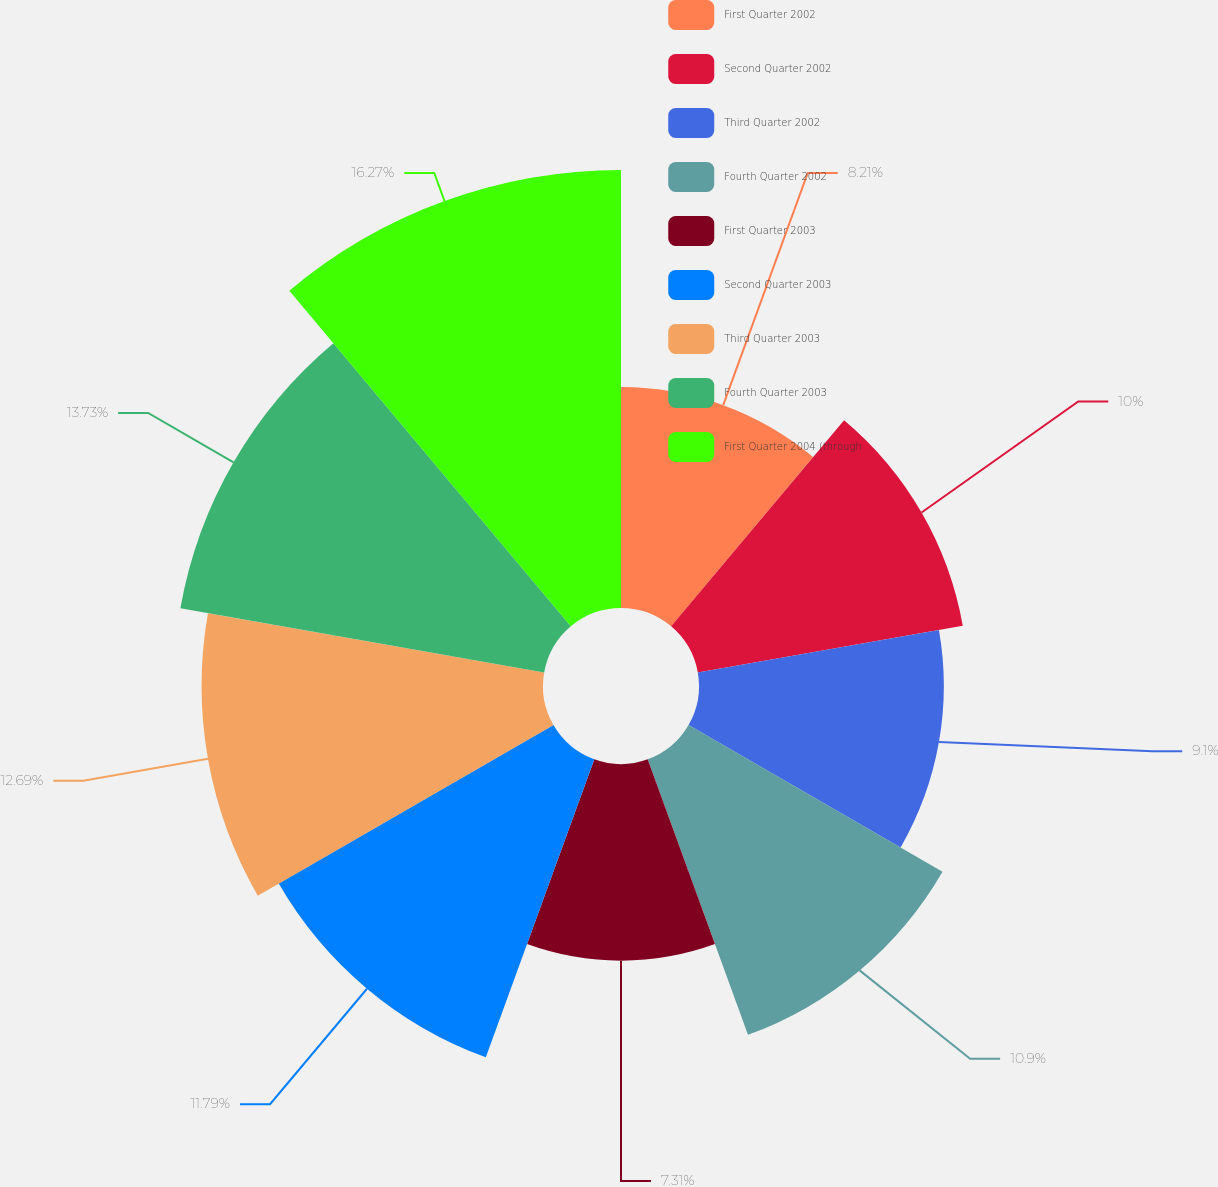<chart> <loc_0><loc_0><loc_500><loc_500><pie_chart><fcel>First Quarter 2002<fcel>Second Quarter 2002<fcel>Third Quarter 2002<fcel>Fourth Quarter 2002<fcel>First Quarter 2003<fcel>Second Quarter 2003<fcel>Third Quarter 2003<fcel>Fourth Quarter 2003<fcel>First Quarter 2004 (through<nl><fcel>8.21%<fcel>10.0%<fcel>9.1%<fcel>10.9%<fcel>7.31%<fcel>11.79%<fcel>12.69%<fcel>13.73%<fcel>16.28%<nl></chart> 